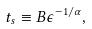Convert formula to latex. <formula><loc_0><loc_0><loc_500><loc_500>t _ { s } \equiv B \epsilon ^ { - 1 / \alpha } ,</formula> 